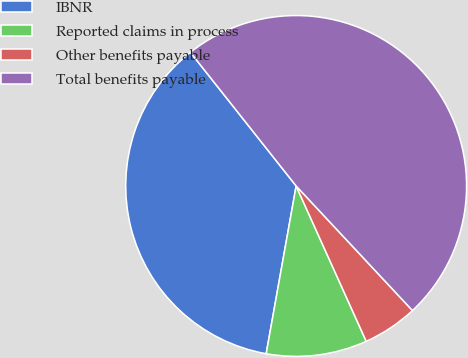Convert chart to OTSL. <chart><loc_0><loc_0><loc_500><loc_500><pie_chart><fcel>IBNR<fcel>Reported claims in process<fcel>Other benefits payable<fcel>Total benefits payable<nl><fcel>36.53%<fcel>9.56%<fcel>5.21%<fcel>48.7%<nl></chart> 